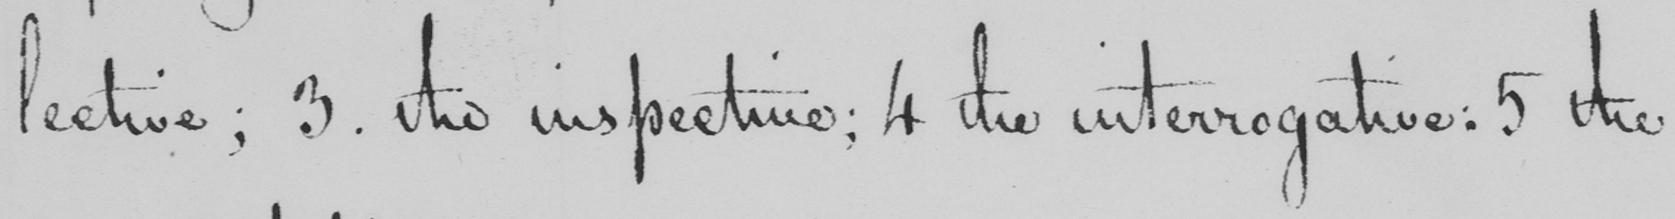Please transcribe the handwritten text in this image. lective ; 3 . the inspective ; 4 the interrogative :  5 . the 